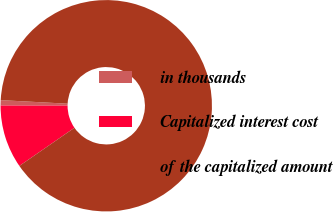Convert chart. <chart><loc_0><loc_0><loc_500><loc_500><pie_chart><fcel>in thousands<fcel>Capitalized interest cost<fcel>of the capitalized amount<nl><fcel>0.81%<fcel>9.68%<fcel>89.52%<nl></chart> 